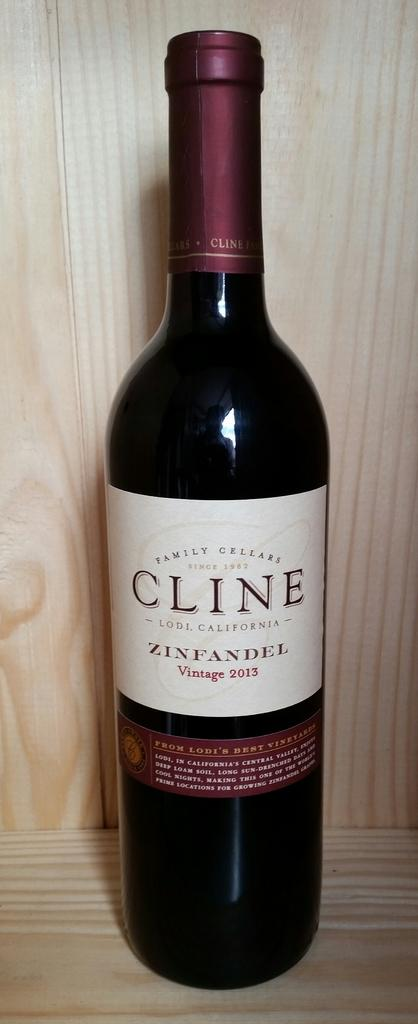Provide a one-sentence caption for the provided image. A zinfandel wine bottle from 2013 sitting on a wood surface. 